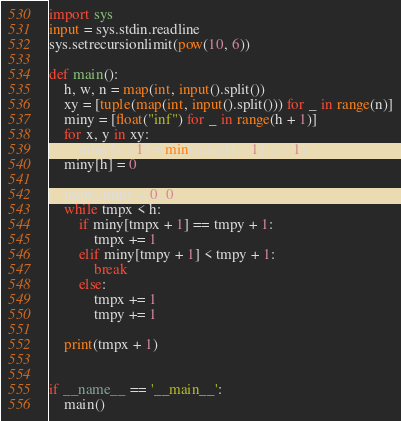Convert code to text. <code><loc_0><loc_0><loc_500><loc_500><_Python_>import sys
input = sys.stdin.readline
sys.setrecursionlimit(pow(10, 6))

def main():
    h, w, n = map(int, input().split())
    xy = [tuple(map(int, input().split())) for _ in range(n)]
    miny = [float("inf") for _ in range(h + 1)]
    for x, y in xy:
        miny[x - 1] = min(miny[x - 1], y - 1)
    miny[h] = 0
    
    tmpx, tmpy = 0, 0
    while tmpx < h:
        if miny[tmpx + 1] == tmpy + 1:
            tmpx += 1
        elif miny[tmpy + 1] < tmpy + 1:
            break
        else:
            tmpx += 1
            tmpy += 1
    
    print(tmpx + 1)


if __name__ == '__main__':
    main()
</code> 